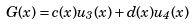Convert formula to latex. <formula><loc_0><loc_0><loc_500><loc_500>G ( x ) = c ( x ) u _ { 3 } ( x ) + d ( x ) u _ { 4 } ( x )</formula> 